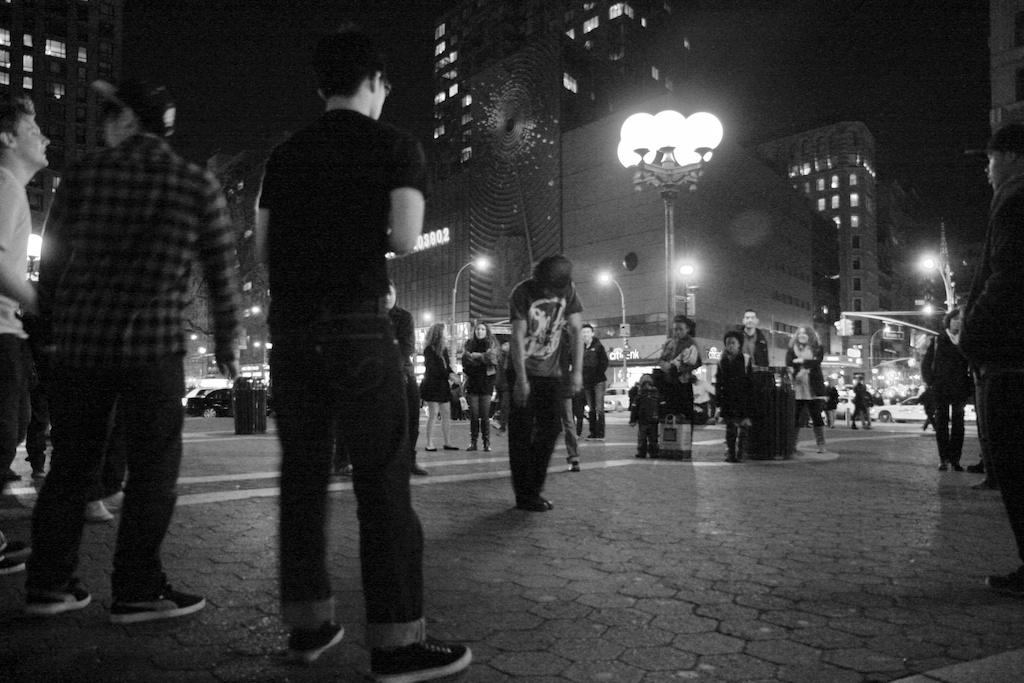What is the color scheme of the image? The image is black and white. What can be seen in the image besides the color scheme? There is a group of people, poles, lights, and buildings in the image. Can you describe the lighting in the image? There are lights in the image. What is the background of the image like? The background of the image is dark. How many cows are present in the image? There are no cows present in the image. What type of horn is featured on the fifth person in the image? There is no fifth person in the image, and no one is depicted with a horn. 